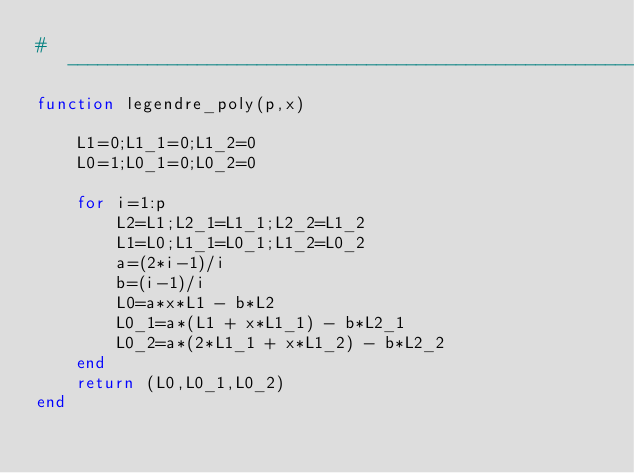Convert code to text. <code><loc_0><loc_0><loc_500><loc_500><_Julia_>#---------------------------------------------------------------------#
function legendre_poly(p,x)

    L1=0;L1_1=0;L1_2=0
    L0=1;L0_1=0;L0_2=0

    for i=1:p
        L2=L1;L2_1=L1_1;L2_2=L1_2
        L1=L0;L1_1=L0_1;L1_2=L0_2
        a=(2*i-1)/i
        b=(i-1)/i
        L0=a*x*L1 - b*L2
        L0_1=a*(L1 + x*L1_1) - b*L2_1
        L0_2=a*(2*L1_1 + x*L1_2) - b*L2_2
    end
    return (L0,L0_1,L0_2)
end
</code> 